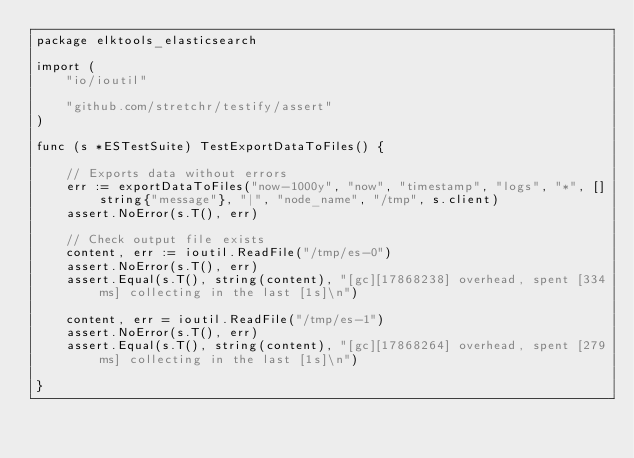<code> <loc_0><loc_0><loc_500><loc_500><_Go_>package elktools_elasticsearch

import (
	"io/ioutil"

	"github.com/stretchr/testify/assert"
)

func (s *ESTestSuite) TestExportDataToFiles() {

	// Exports data without errors
	err := exportDataToFiles("now-1000y", "now", "timestamp", "logs", "*", []string{"message"}, "|", "node_name", "/tmp", s.client)
	assert.NoError(s.T(), err)

	// Check output file exists
	content, err := ioutil.ReadFile("/tmp/es-0")
	assert.NoError(s.T(), err)
	assert.Equal(s.T(), string(content), "[gc][17868238] overhead, spent [334ms] collecting in the last [1s]\n")

	content, err = ioutil.ReadFile("/tmp/es-1")
	assert.NoError(s.T(), err)
	assert.Equal(s.T(), string(content), "[gc][17868264] overhead, spent [279ms] collecting in the last [1s]\n")

}
</code> 